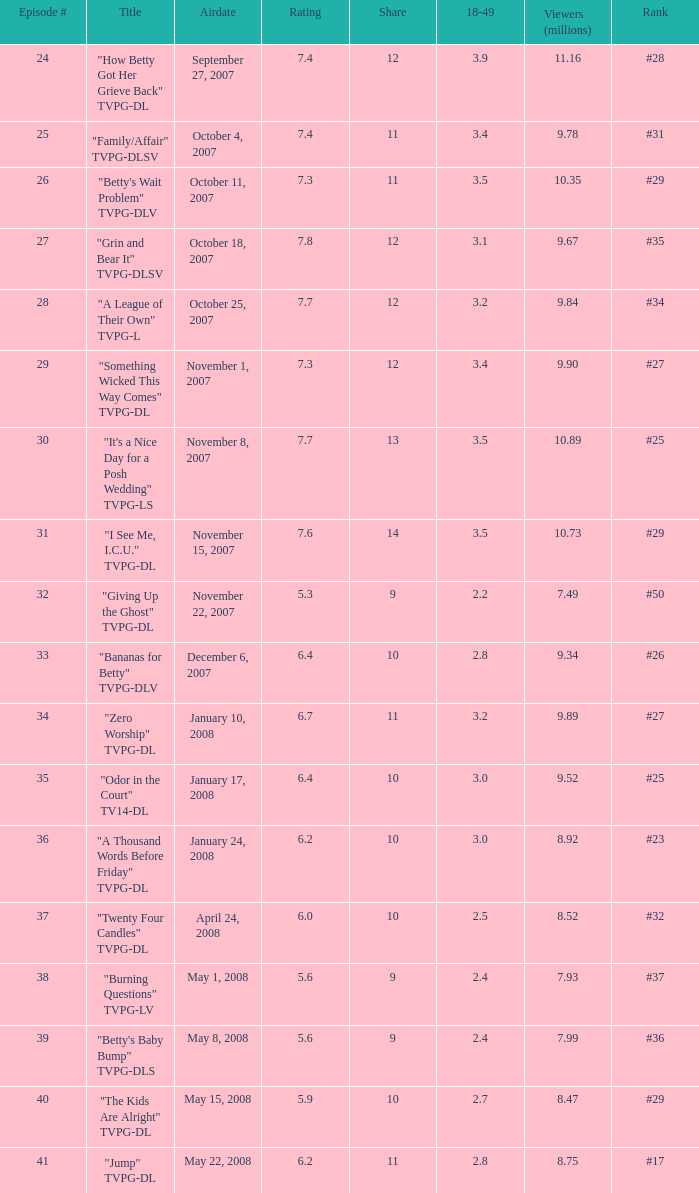On which date did the episode ranked #29 with a share greater than 10 get broadcasted? May 15, 2008. 